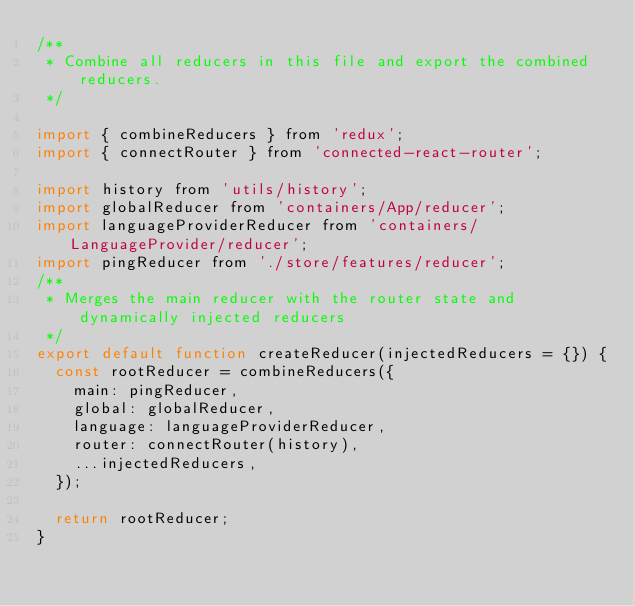<code> <loc_0><loc_0><loc_500><loc_500><_JavaScript_>/**
 * Combine all reducers in this file and export the combined reducers.
 */

import { combineReducers } from 'redux';
import { connectRouter } from 'connected-react-router';

import history from 'utils/history';
import globalReducer from 'containers/App/reducer';
import languageProviderReducer from 'containers/LanguageProvider/reducer';
import pingReducer from './store/features/reducer';
/**
 * Merges the main reducer with the router state and dynamically injected reducers
 */
export default function createReducer(injectedReducers = {}) {
  const rootReducer = combineReducers({
    main: pingReducer,
    global: globalReducer,
    language: languageProviderReducer,
    router: connectRouter(history),
    ...injectedReducers,
  });

  return rootReducer;
}
</code> 